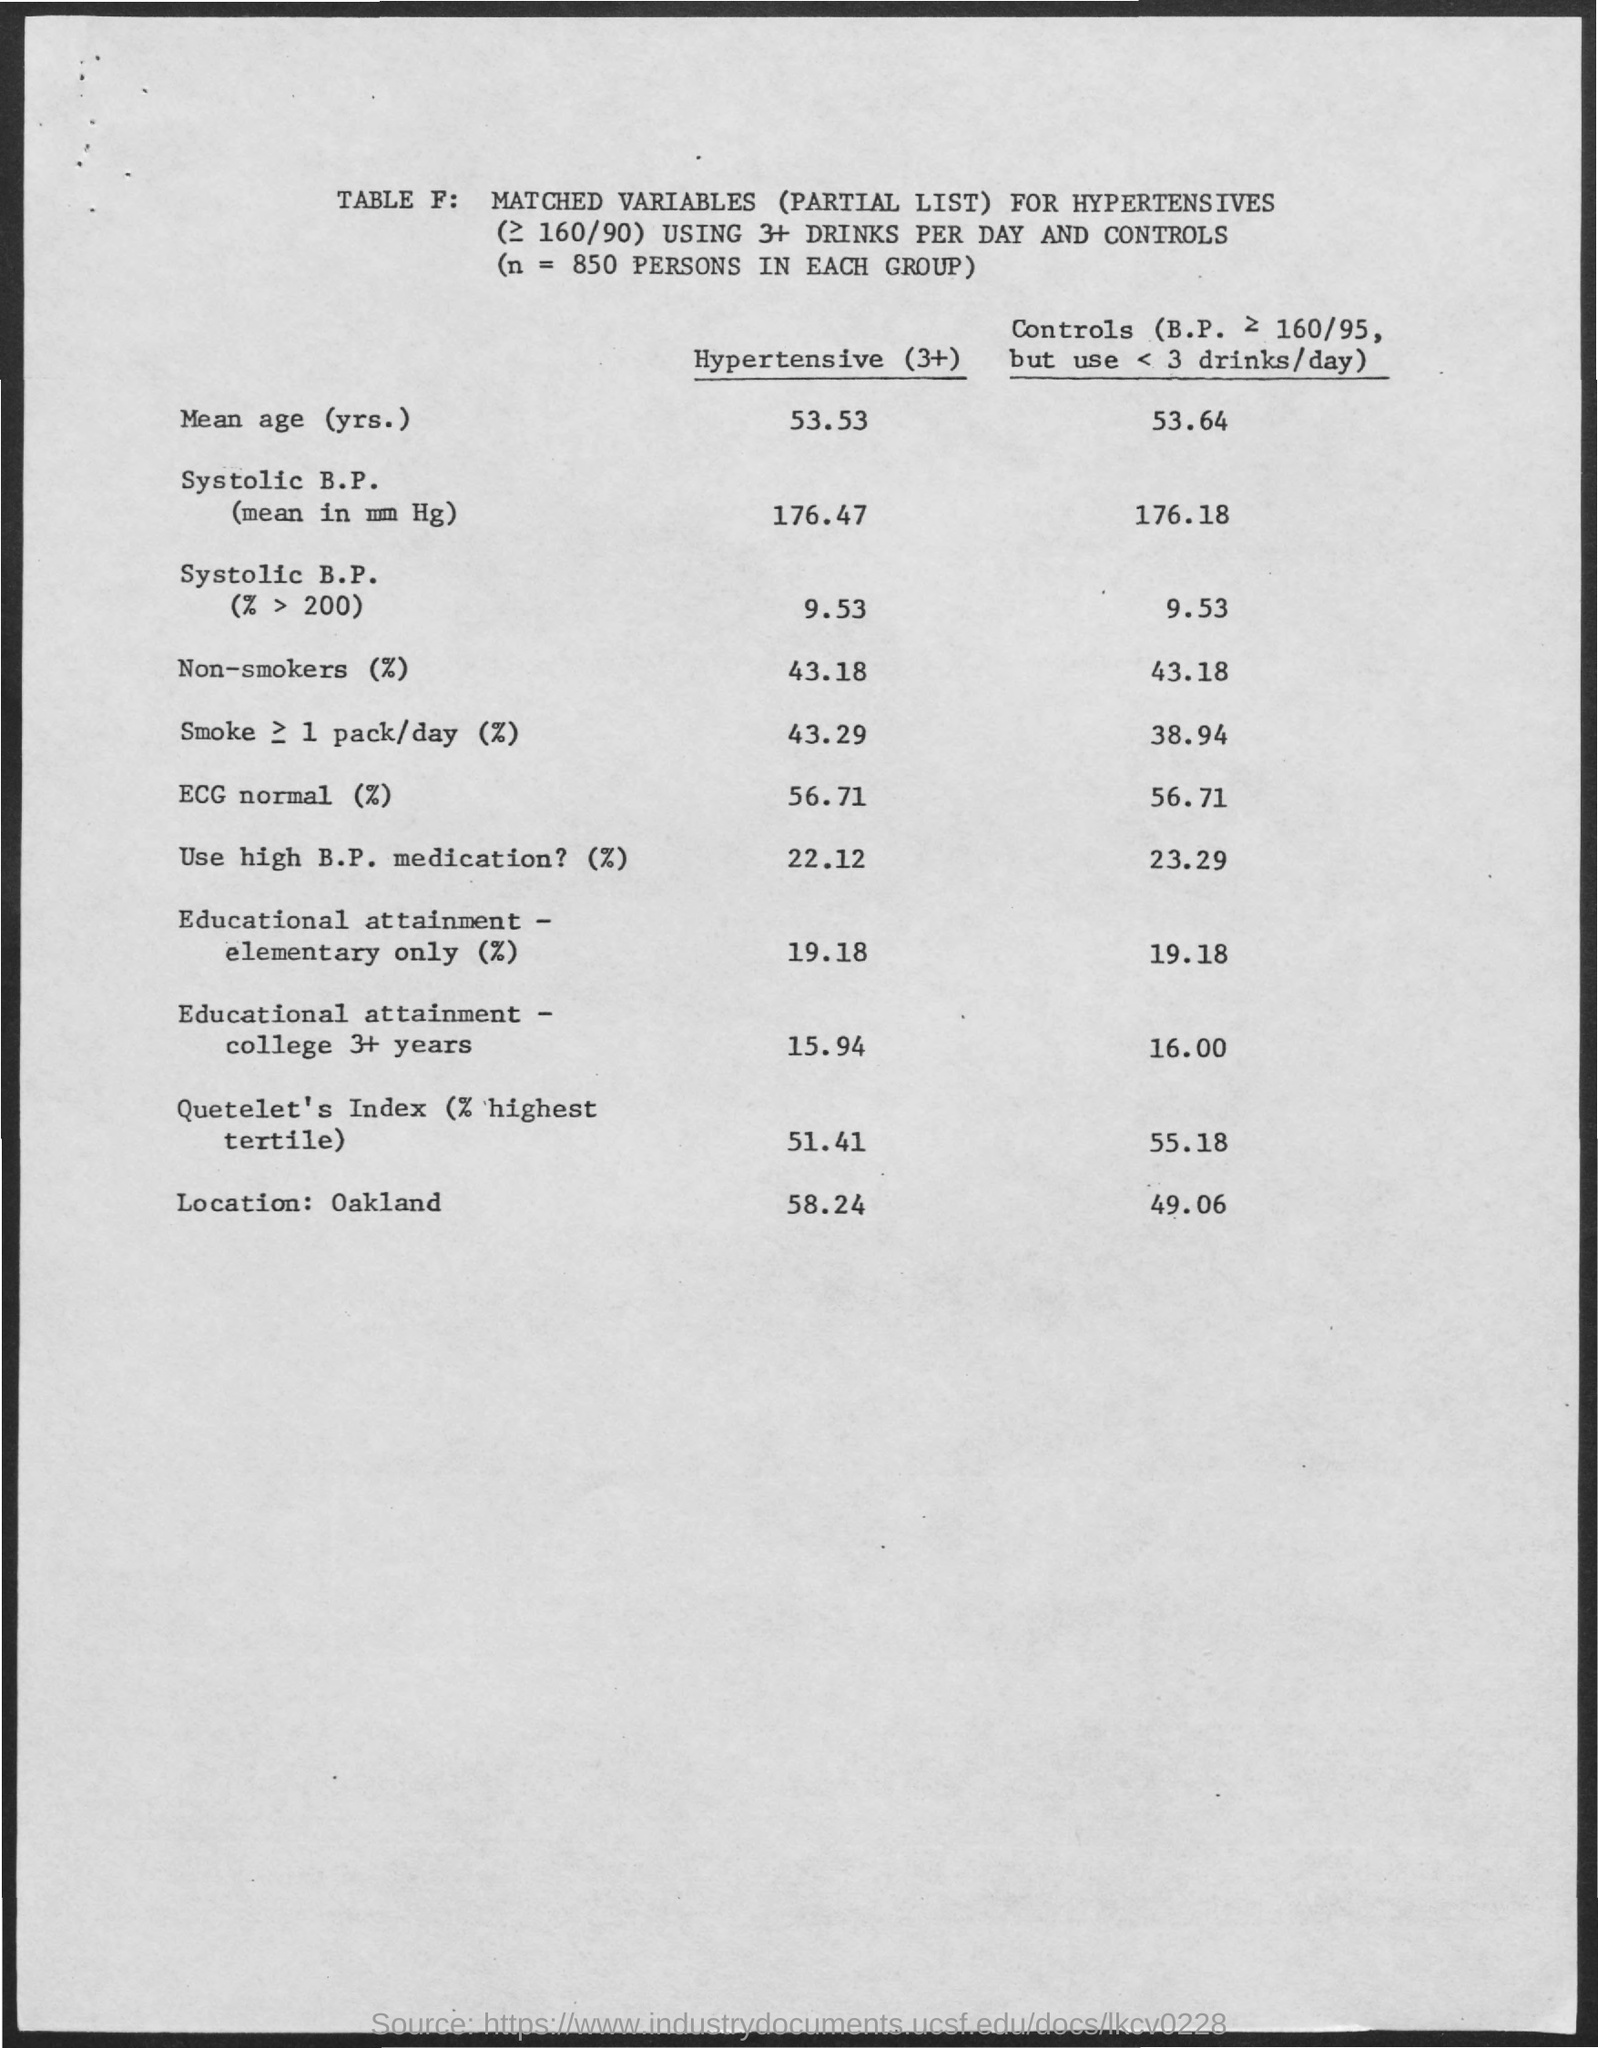What is n equal to?
Your answer should be compact. 850 persons in each group. What is the unit of Systolic B.P.?
Provide a short and direct response. Mean in mm hg. 